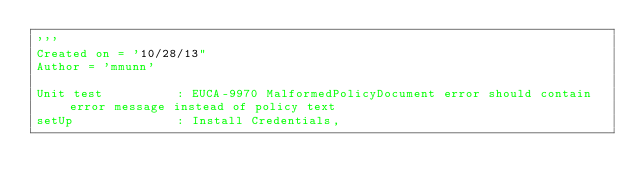<code> <loc_0><loc_0><loc_500><loc_500><_Python_>'''
Created on = '10/28/13"
Author = 'mmunn'

Unit test          : EUCA-9970 MalformedPolicyDocument error should contain error message instead of policy text
setUp              : Install Credentials,</code> 